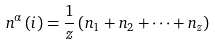<formula> <loc_0><loc_0><loc_500><loc_500>n ^ { \alpha } \left ( i \right ) = \frac { 1 } { z } \left ( n _ { 1 } + n _ { 2 } + \dots + n _ { z } \right )</formula> 